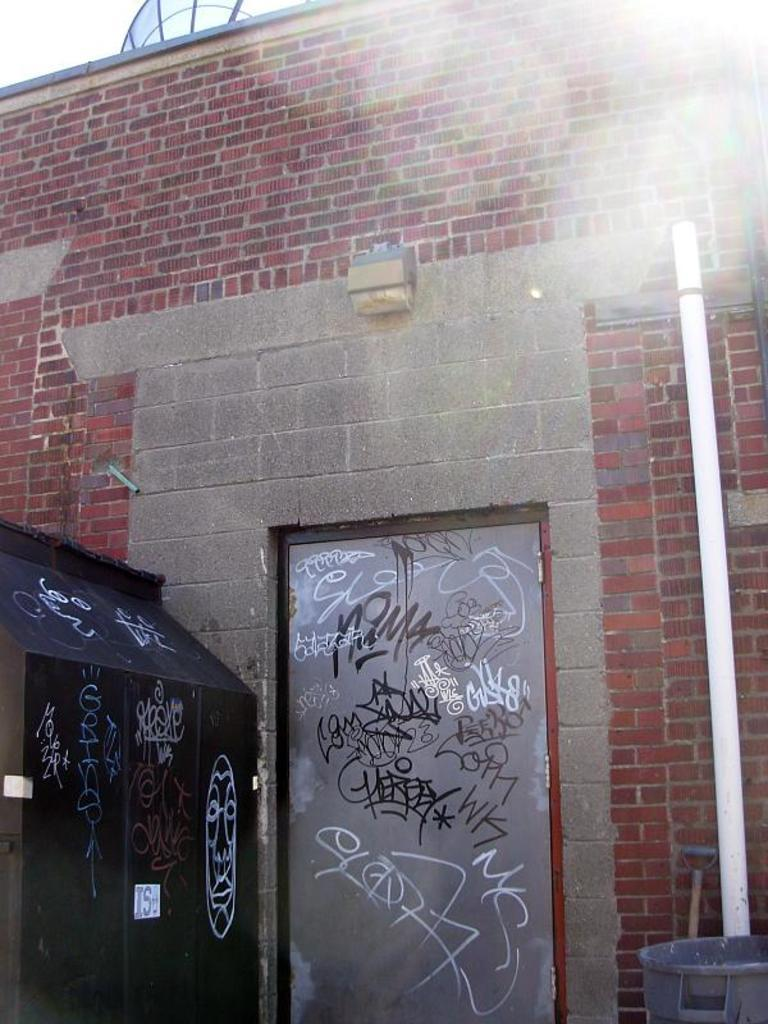What is a prominent feature in the image? There is a wall in the image. What is a part of the wall that allows access? There is a door in the wall. What object is attached to the side of the wall? There is a black box on the side of the wall. Can you see your partner climbing the mountain in the image? There is no mountain or partner present in the image; it only features a wall with a door and a black box. 